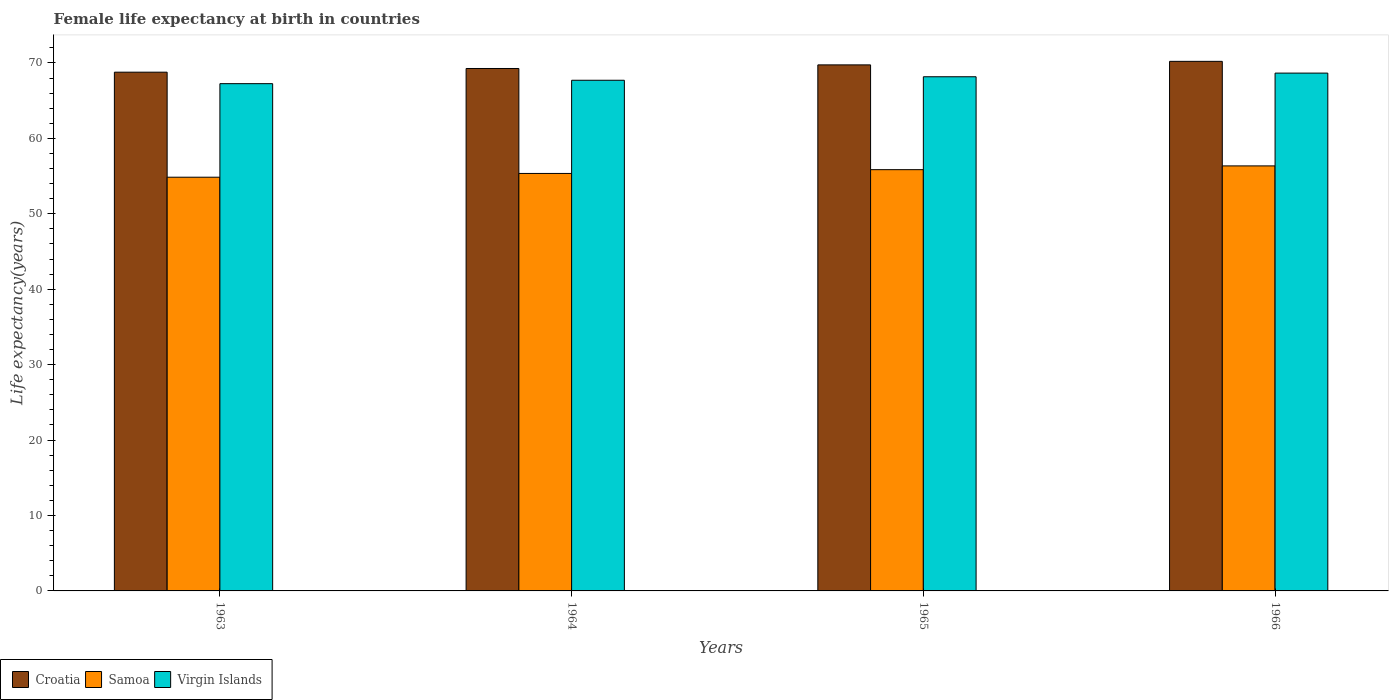How many different coloured bars are there?
Offer a terse response. 3. Are the number of bars on each tick of the X-axis equal?
Keep it short and to the point. Yes. How many bars are there on the 4th tick from the left?
Your response must be concise. 3. What is the label of the 4th group of bars from the left?
Your response must be concise. 1966. In how many cases, is the number of bars for a given year not equal to the number of legend labels?
Offer a terse response. 0. What is the female life expectancy at birth in Croatia in 1966?
Ensure brevity in your answer.  70.21. Across all years, what is the maximum female life expectancy at birth in Croatia?
Your answer should be very brief. 70.21. Across all years, what is the minimum female life expectancy at birth in Virgin Islands?
Make the answer very short. 67.25. In which year was the female life expectancy at birth in Samoa maximum?
Ensure brevity in your answer.  1966. In which year was the female life expectancy at birth in Virgin Islands minimum?
Give a very brief answer. 1963. What is the total female life expectancy at birth in Virgin Islands in the graph?
Give a very brief answer. 271.78. What is the difference between the female life expectancy at birth in Croatia in 1963 and that in 1965?
Your answer should be compact. -0.97. What is the difference between the female life expectancy at birth in Virgin Islands in 1965 and the female life expectancy at birth in Croatia in 1963?
Make the answer very short. -0.61. What is the average female life expectancy at birth in Virgin Islands per year?
Keep it short and to the point. 67.95. In the year 1965, what is the difference between the female life expectancy at birth in Samoa and female life expectancy at birth in Virgin Islands?
Keep it short and to the point. -12.32. What is the ratio of the female life expectancy at birth in Virgin Islands in 1964 to that in 1965?
Your response must be concise. 0.99. Is the female life expectancy at birth in Croatia in 1965 less than that in 1966?
Offer a terse response. Yes. Is the difference between the female life expectancy at birth in Samoa in 1963 and 1964 greater than the difference between the female life expectancy at birth in Virgin Islands in 1963 and 1964?
Provide a short and direct response. No. What is the difference between the highest and the lowest female life expectancy at birth in Virgin Islands?
Ensure brevity in your answer.  1.4. In how many years, is the female life expectancy at birth in Samoa greater than the average female life expectancy at birth in Samoa taken over all years?
Keep it short and to the point. 2. Is the sum of the female life expectancy at birth in Samoa in 1963 and 1964 greater than the maximum female life expectancy at birth in Croatia across all years?
Your response must be concise. Yes. What does the 1st bar from the left in 1963 represents?
Offer a terse response. Croatia. What does the 3rd bar from the right in 1965 represents?
Your answer should be very brief. Croatia. Is it the case that in every year, the sum of the female life expectancy at birth in Croatia and female life expectancy at birth in Samoa is greater than the female life expectancy at birth in Virgin Islands?
Provide a succinct answer. Yes. Are all the bars in the graph horizontal?
Make the answer very short. No. Does the graph contain any zero values?
Provide a short and direct response. No. Does the graph contain grids?
Offer a very short reply. No. Where does the legend appear in the graph?
Ensure brevity in your answer.  Bottom left. What is the title of the graph?
Give a very brief answer. Female life expectancy at birth in countries. What is the label or title of the Y-axis?
Give a very brief answer. Life expectancy(years). What is the Life expectancy(years) in Croatia in 1963?
Your response must be concise. 68.78. What is the Life expectancy(years) in Samoa in 1963?
Ensure brevity in your answer.  54.85. What is the Life expectancy(years) of Virgin Islands in 1963?
Your answer should be very brief. 67.25. What is the Life expectancy(years) in Croatia in 1964?
Keep it short and to the point. 69.27. What is the Life expectancy(years) in Samoa in 1964?
Offer a very short reply. 55.35. What is the Life expectancy(years) in Virgin Islands in 1964?
Provide a succinct answer. 67.7. What is the Life expectancy(years) in Croatia in 1965?
Keep it short and to the point. 69.74. What is the Life expectancy(years) in Samoa in 1965?
Ensure brevity in your answer.  55.85. What is the Life expectancy(years) of Virgin Islands in 1965?
Keep it short and to the point. 68.17. What is the Life expectancy(years) in Croatia in 1966?
Ensure brevity in your answer.  70.21. What is the Life expectancy(years) of Samoa in 1966?
Give a very brief answer. 56.35. What is the Life expectancy(years) in Virgin Islands in 1966?
Make the answer very short. 68.65. Across all years, what is the maximum Life expectancy(years) of Croatia?
Your answer should be compact. 70.21. Across all years, what is the maximum Life expectancy(years) in Samoa?
Ensure brevity in your answer.  56.35. Across all years, what is the maximum Life expectancy(years) of Virgin Islands?
Make the answer very short. 68.65. Across all years, what is the minimum Life expectancy(years) of Croatia?
Ensure brevity in your answer.  68.78. Across all years, what is the minimum Life expectancy(years) in Samoa?
Your response must be concise. 54.85. Across all years, what is the minimum Life expectancy(years) in Virgin Islands?
Keep it short and to the point. 67.25. What is the total Life expectancy(years) of Croatia in the graph?
Provide a succinct answer. 278. What is the total Life expectancy(years) of Samoa in the graph?
Offer a terse response. 222.4. What is the total Life expectancy(years) in Virgin Islands in the graph?
Your response must be concise. 271.78. What is the difference between the Life expectancy(years) in Croatia in 1963 and that in 1964?
Provide a succinct answer. -0.49. What is the difference between the Life expectancy(years) of Samoa in 1963 and that in 1964?
Offer a terse response. -0.5. What is the difference between the Life expectancy(years) of Virgin Islands in 1963 and that in 1964?
Ensure brevity in your answer.  -0.45. What is the difference between the Life expectancy(years) in Croatia in 1963 and that in 1965?
Offer a very short reply. -0.97. What is the difference between the Life expectancy(years) of Virgin Islands in 1963 and that in 1965?
Provide a succinct answer. -0.92. What is the difference between the Life expectancy(years) of Croatia in 1963 and that in 1966?
Provide a succinct answer. -1.44. What is the difference between the Life expectancy(years) of Virgin Islands in 1963 and that in 1966?
Keep it short and to the point. -1.4. What is the difference between the Life expectancy(years) in Croatia in 1964 and that in 1965?
Your response must be concise. -0.48. What is the difference between the Life expectancy(years) in Virgin Islands in 1964 and that in 1965?
Make the answer very short. -0.47. What is the difference between the Life expectancy(years) of Croatia in 1964 and that in 1966?
Ensure brevity in your answer.  -0.95. What is the difference between the Life expectancy(years) in Virgin Islands in 1964 and that in 1966?
Make the answer very short. -0.95. What is the difference between the Life expectancy(years) of Croatia in 1965 and that in 1966?
Give a very brief answer. -0.47. What is the difference between the Life expectancy(years) of Samoa in 1965 and that in 1966?
Make the answer very short. -0.5. What is the difference between the Life expectancy(years) of Virgin Islands in 1965 and that in 1966?
Give a very brief answer. -0.48. What is the difference between the Life expectancy(years) in Croatia in 1963 and the Life expectancy(years) in Samoa in 1964?
Your answer should be very brief. 13.43. What is the difference between the Life expectancy(years) in Croatia in 1963 and the Life expectancy(years) in Virgin Islands in 1964?
Provide a short and direct response. 1.07. What is the difference between the Life expectancy(years) of Samoa in 1963 and the Life expectancy(years) of Virgin Islands in 1964?
Your response must be concise. -12.85. What is the difference between the Life expectancy(years) in Croatia in 1963 and the Life expectancy(years) in Samoa in 1965?
Offer a terse response. 12.93. What is the difference between the Life expectancy(years) of Croatia in 1963 and the Life expectancy(years) of Virgin Islands in 1965?
Make the answer very short. 0.61. What is the difference between the Life expectancy(years) of Samoa in 1963 and the Life expectancy(years) of Virgin Islands in 1965?
Your answer should be compact. -13.32. What is the difference between the Life expectancy(years) of Croatia in 1963 and the Life expectancy(years) of Samoa in 1966?
Your answer should be compact. 12.43. What is the difference between the Life expectancy(years) of Croatia in 1963 and the Life expectancy(years) of Virgin Islands in 1966?
Keep it short and to the point. 0.12. What is the difference between the Life expectancy(years) in Samoa in 1963 and the Life expectancy(years) in Virgin Islands in 1966?
Give a very brief answer. -13.8. What is the difference between the Life expectancy(years) of Croatia in 1964 and the Life expectancy(years) of Samoa in 1965?
Ensure brevity in your answer.  13.41. What is the difference between the Life expectancy(years) of Croatia in 1964 and the Life expectancy(years) of Virgin Islands in 1965?
Give a very brief answer. 1.1. What is the difference between the Life expectancy(years) in Samoa in 1964 and the Life expectancy(years) in Virgin Islands in 1965?
Offer a terse response. -12.82. What is the difference between the Life expectancy(years) of Croatia in 1964 and the Life expectancy(years) of Samoa in 1966?
Ensure brevity in your answer.  12.91. What is the difference between the Life expectancy(years) in Croatia in 1964 and the Life expectancy(years) in Virgin Islands in 1966?
Give a very brief answer. 0.61. What is the difference between the Life expectancy(years) of Samoa in 1964 and the Life expectancy(years) of Virgin Islands in 1966?
Provide a short and direct response. -13.3. What is the difference between the Life expectancy(years) of Croatia in 1965 and the Life expectancy(years) of Samoa in 1966?
Provide a succinct answer. 13.39. What is the difference between the Life expectancy(years) of Croatia in 1965 and the Life expectancy(years) of Virgin Islands in 1966?
Offer a very short reply. 1.09. What is the difference between the Life expectancy(years) of Samoa in 1965 and the Life expectancy(years) of Virgin Islands in 1966?
Your answer should be compact. -12.8. What is the average Life expectancy(years) in Croatia per year?
Your answer should be very brief. 69.5. What is the average Life expectancy(years) of Samoa per year?
Make the answer very short. 55.6. What is the average Life expectancy(years) of Virgin Islands per year?
Your response must be concise. 67.95. In the year 1963, what is the difference between the Life expectancy(years) of Croatia and Life expectancy(years) of Samoa?
Your answer should be very brief. 13.93. In the year 1963, what is the difference between the Life expectancy(years) of Croatia and Life expectancy(years) of Virgin Islands?
Offer a terse response. 1.52. In the year 1963, what is the difference between the Life expectancy(years) of Samoa and Life expectancy(years) of Virgin Islands?
Make the answer very short. -12.4. In the year 1964, what is the difference between the Life expectancy(years) of Croatia and Life expectancy(years) of Samoa?
Your answer should be compact. 13.91. In the year 1964, what is the difference between the Life expectancy(years) in Croatia and Life expectancy(years) in Virgin Islands?
Provide a short and direct response. 1.56. In the year 1964, what is the difference between the Life expectancy(years) of Samoa and Life expectancy(years) of Virgin Islands?
Your answer should be very brief. -12.35. In the year 1965, what is the difference between the Life expectancy(years) in Croatia and Life expectancy(years) in Samoa?
Your response must be concise. 13.89. In the year 1965, what is the difference between the Life expectancy(years) in Croatia and Life expectancy(years) in Virgin Islands?
Your answer should be compact. 1.57. In the year 1965, what is the difference between the Life expectancy(years) of Samoa and Life expectancy(years) of Virgin Islands?
Offer a very short reply. -12.32. In the year 1966, what is the difference between the Life expectancy(years) of Croatia and Life expectancy(years) of Samoa?
Ensure brevity in your answer.  13.86. In the year 1966, what is the difference between the Life expectancy(years) of Croatia and Life expectancy(years) of Virgin Islands?
Give a very brief answer. 1.56. In the year 1966, what is the difference between the Life expectancy(years) in Samoa and Life expectancy(years) in Virgin Islands?
Give a very brief answer. -12.3. What is the ratio of the Life expectancy(years) in Croatia in 1963 to that in 1964?
Your answer should be very brief. 0.99. What is the ratio of the Life expectancy(years) of Croatia in 1963 to that in 1965?
Ensure brevity in your answer.  0.99. What is the ratio of the Life expectancy(years) in Samoa in 1963 to that in 1965?
Offer a very short reply. 0.98. What is the ratio of the Life expectancy(years) of Virgin Islands in 1963 to that in 1965?
Your answer should be compact. 0.99. What is the ratio of the Life expectancy(years) of Croatia in 1963 to that in 1966?
Keep it short and to the point. 0.98. What is the ratio of the Life expectancy(years) in Samoa in 1963 to that in 1966?
Give a very brief answer. 0.97. What is the ratio of the Life expectancy(years) of Virgin Islands in 1963 to that in 1966?
Give a very brief answer. 0.98. What is the ratio of the Life expectancy(years) in Croatia in 1964 to that in 1965?
Give a very brief answer. 0.99. What is the ratio of the Life expectancy(years) in Samoa in 1964 to that in 1965?
Provide a succinct answer. 0.99. What is the ratio of the Life expectancy(years) of Virgin Islands in 1964 to that in 1965?
Keep it short and to the point. 0.99. What is the ratio of the Life expectancy(years) of Croatia in 1964 to that in 1966?
Your response must be concise. 0.99. What is the ratio of the Life expectancy(years) of Samoa in 1964 to that in 1966?
Give a very brief answer. 0.98. What is the ratio of the Life expectancy(years) of Virgin Islands in 1964 to that in 1966?
Provide a succinct answer. 0.99. What is the ratio of the Life expectancy(years) of Croatia in 1965 to that in 1966?
Your response must be concise. 0.99. What is the ratio of the Life expectancy(years) of Samoa in 1965 to that in 1966?
Offer a terse response. 0.99. What is the difference between the highest and the second highest Life expectancy(years) of Croatia?
Keep it short and to the point. 0.47. What is the difference between the highest and the second highest Life expectancy(years) in Virgin Islands?
Provide a succinct answer. 0.48. What is the difference between the highest and the lowest Life expectancy(years) in Croatia?
Make the answer very short. 1.44. What is the difference between the highest and the lowest Life expectancy(years) of Virgin Islands?
Provide a succinct answer. 1.4. 